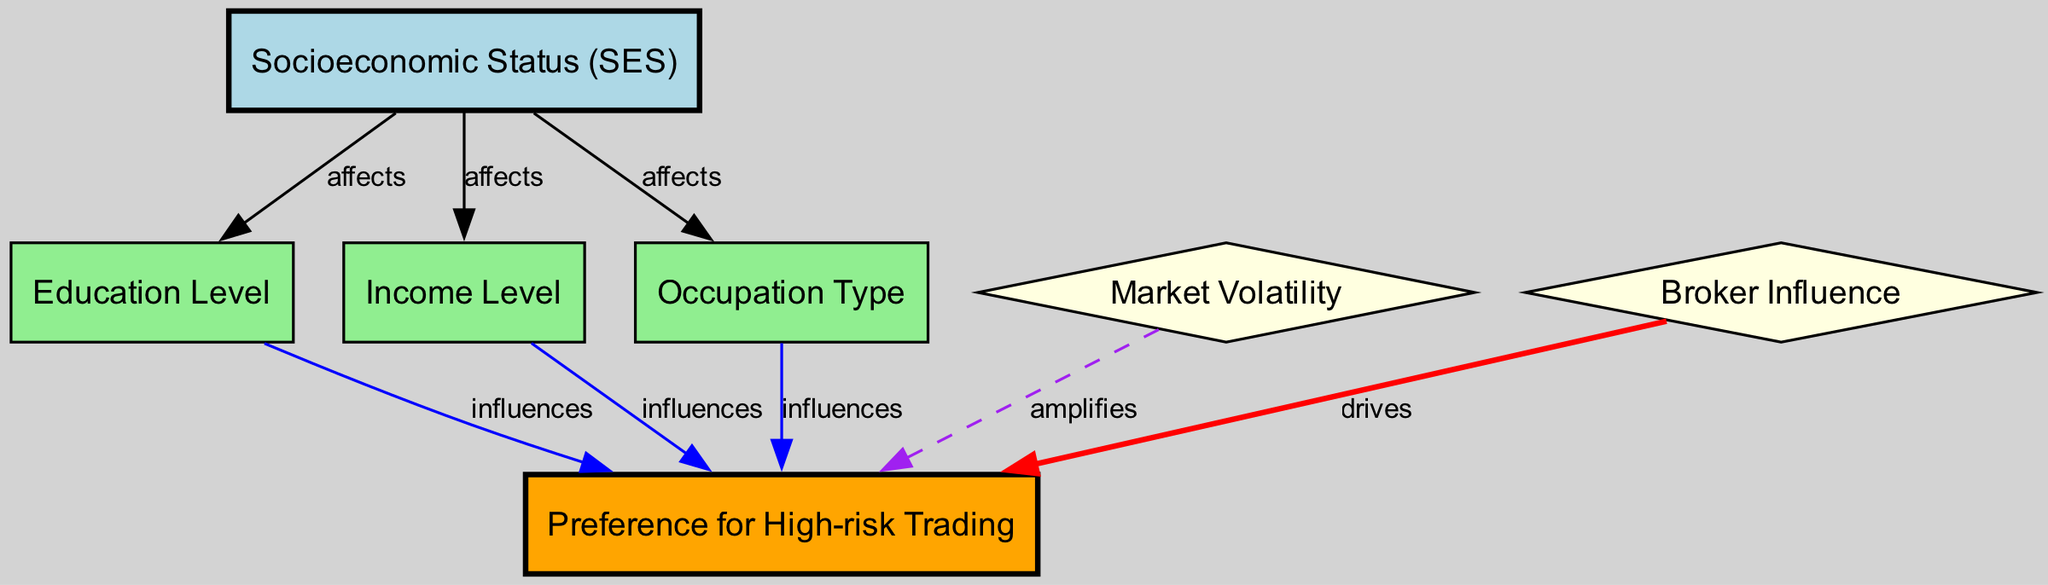What's the total number of nodes in the diagram? The diagram includes a list of nodes: Socioeconomic Status, Education Level, Income Level, Occupation Type, Preference for High-risk Trading, Market Volatility, and Broker Influence. Counting these gives a total of seven nodes.
Answer: 7 How many edges connect to the "Preference for High-risk Trading" node? The edges that connect to the "Preference for High-risk Trading" node are from Education Level, Income Level, Occupation Type, Market Volatility, and Broker Influence. This totals five edges.
Answer: 5 Which node influences the "Preference for High-risk Trading" by highlighting educational impact? The node "Education Level" has the labeled edge "influences" pointing to "Preference for High-risk Trading," highlighting that education impacts trading preferences.
Answer: Education Level What type of edge connects "Market Volatility" to "Preference for High-risk Trading"? The edge between "Market Volatility" and "Preference for High-risk Trading" is labeled "amplifies," indicating a strengthening effect. This edge is shown as a dashed purple line in the diagram.
Answer: amplifies Which node is affected by the "Socioeconomic Status" node? The node "Income Level" is one of the nodes that is affected by "Socioeconomic Status," establishing a direct relationship as shown in the diagram.
Answer: Income Level Which node drives the "Preference for High-risk Trading"? The diagram has an edge from the node "Broker Influence" to "Preference for High-risk Trading," labeled "drives," indicating that broker influence is a key factor in driving the preference.
Answer: Broker Influence How many types of edges are depicted in the diagram? The diagram displays three distinct types of edges: "affects," "influences," and "drives," with "amplifies" being a specific case of a stronger influence. Counting these gives a total of four edge types.
Answer: 4 What does the "Socioeconomic Status" node affect aside from income? The "Socioeconomic Status" node affects not only the "Income Level" node but also "Education Level" and "Occupation Type," thus influencing various facets of socioeconomic conditions.
Answer: Education Level, Occupation Type What is the relationship between "Occupation Type" and "Preference for High-risk Trading"? The "Occupation Type" node influences "Preference for High-risk Trading," highlighting that the nature of one's job can impact trading behaviors, as shown by the directed edge marked "influences."
Answer: influences 